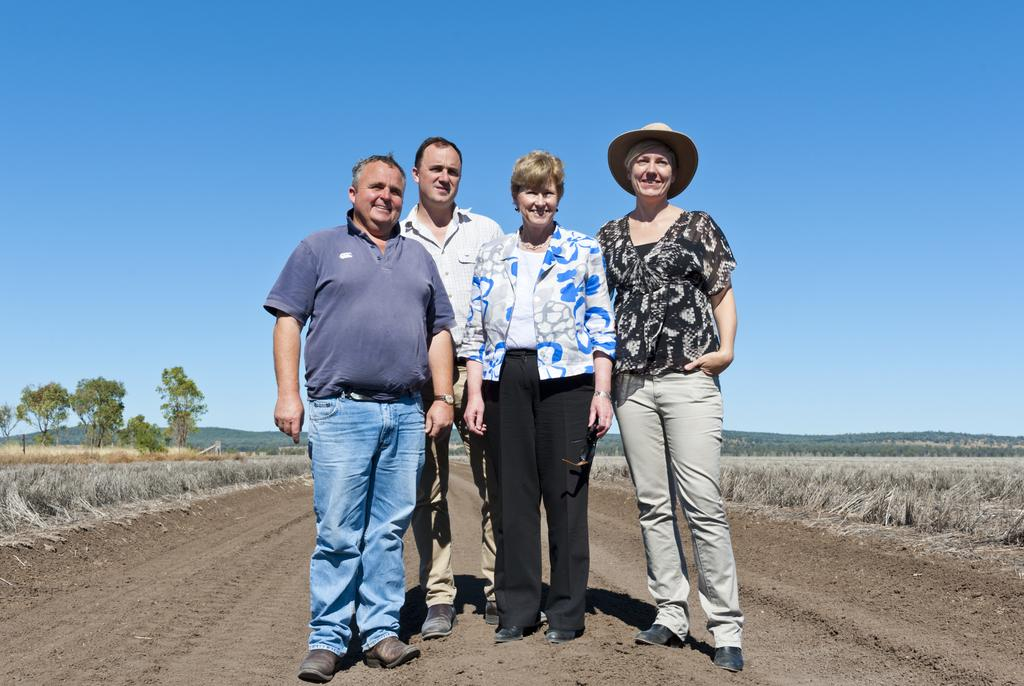What are the people in the image doing? The people in the image are standing on the floor. What type of vegetation can be seen in the image? Plants and trees are visible in the image. What type of punishment is being administered to the people in the image? There is no indication of punishment in the image; the people are simply standing on the floor. 